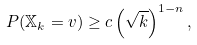<formula> <loc_0><loc_0><loc_500><loc_500>P ( \mathbb { X } _ { k } = v ) \geq c \left ( \sqrt { k } \right ) ^ { 1 - n } ,</formula> 